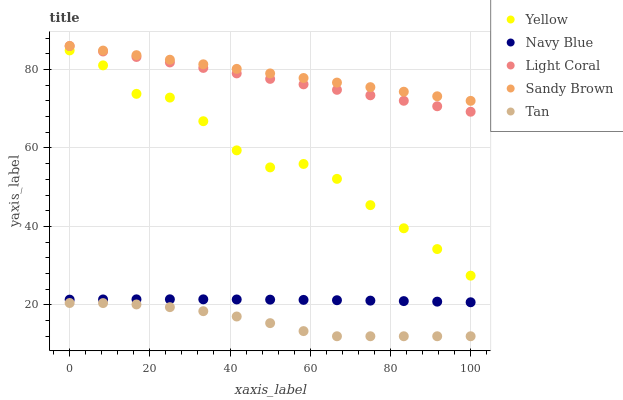Does Tan have the minimum area under the curve?
Answer yes or no. Yes. Does Sandy Brown have the maximum area under the curve?
Answer yes or no. Yes. Does Navy Blue have the minimum area under the curve?
Answer yes or no. No. Does Navy Blue have the maximum area under the curve?
Answer yes or no. No. Is Light Coral the smoothest?
Answer yes or no. Yes. Is Yellow the roughest?
Answer yes or no. Yes. Is Navy Blue the smoothest?
Answer yes or no. No. Is Navy Blue the roughest?
Answer yes or no. No. Does Tan have the lowest value?
Answer yes or no. Yes. Does Navy Blue have the lowest value?
Answer yes or no. No. Does Sandy Brown have the highest value?
Answer yes or no. Yes. Does Navy Blue have the highest value?
Answer yes or no. No. Is Navy Blue less than Light Coral?
Answer yes or no. Yes. Is Sandy Brown greater than Yellow?
Answer yes or no. Yes. Does Sandy Brown intersect Light Coral?
Answer yes or no. Yes. Is Sandy Brown less than Light Coral?
Answer yes or no. No. Is Sandy Brown greater than Light Coral?
Answer yes or no. No. Does Navy Blue intersect Light Coral?
Answer yes or no. No. 